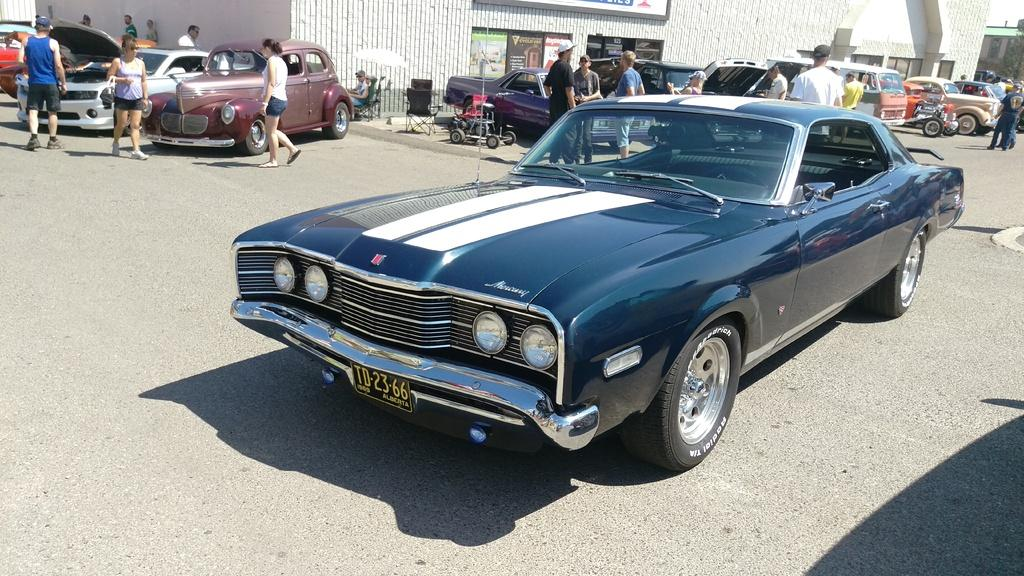What type of vehicles can be seen on the road in the image? There are cars on the road in the image. What are the people in the image doing? People are walking on the road in the image. What can be seen in the background of the image? There is a shop visible in the background of the image. What type of hair is being taught in the image? There is no hair or teaching present in the image; it features cars on the road and people walking. What type of jeans are the cars wearing in the image? Cars do not wear jeans; they are vehicles in the image. 